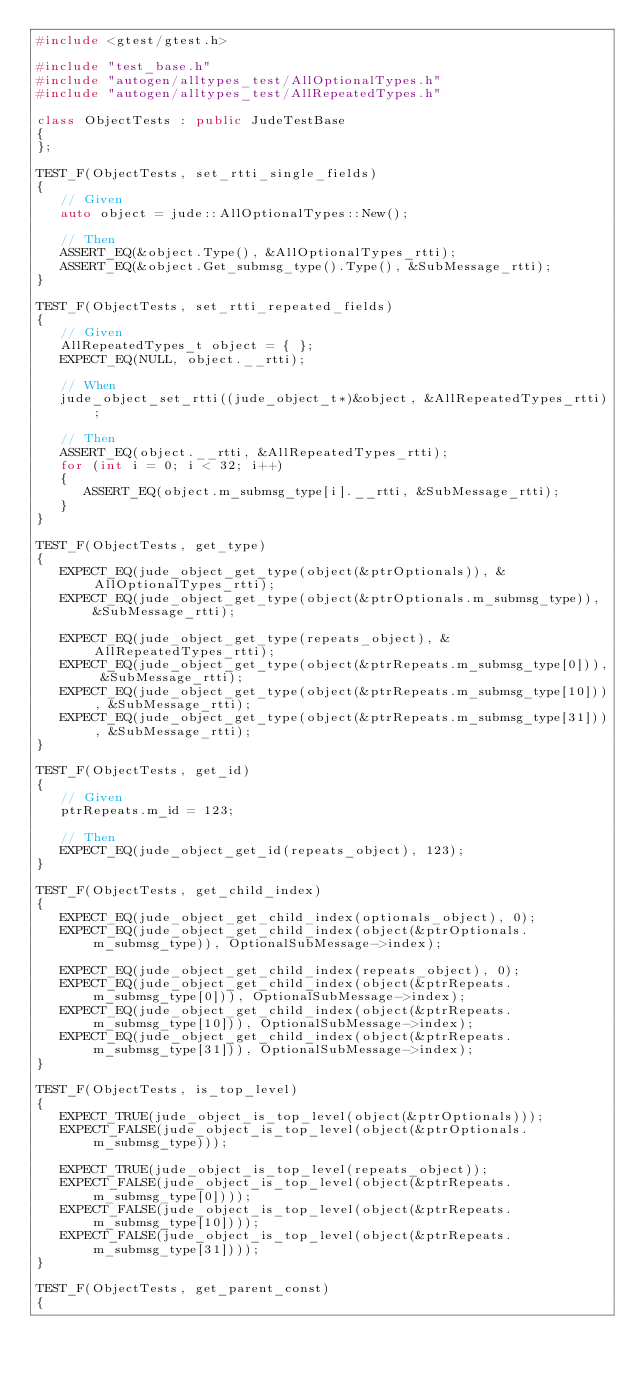Convert code to text. <code><loc_0><loc_0><loc_500><loc_500><_C++_>#include <gtest/gtest.h>

#include "test_base.h"
#include "autogen/alltypes_test/AllOptionalTypes.h"
#include "autogen/alltypes_test/AllRepeatedTypes.h"

class ObjectTests : public JudeTestBase
{
};

TEST_F(ObjectTests, set_rtti_single_fields)
{
   // Given
   auto object = jude::AllOptionalTypes::New();

   // Then
   ASSERT_EQ(&object.Type(), &AllOptionalTypes_rtti);
   ASSERT_EQ(&object.Get_submsg_type().Type(), &SubMessage_rtti);
}

TEST_F(ObjectTests, set_rtti_repeated_fields)
{
   // Given
   AllRepeatedTypes_t object = { };
   EXPECT_EQ(NULL, object.__rtti);

   // When
   jude_object_set_rtti((jude_object_t*)&object, &AllRepeatedTypes_rtti);

   // Then
   ASSERT_EQ(object.__rtti, &AllRepeatedTypes_rtti);
   for (int i = 0; i < 32; i++)
   {
      ASSERT_EQ(object.m_submsg_type[i].__rtti, &SubMessage_rtti);
   }
}

TEST_F(ObjectTests, get_type)
{
   EXPECT_EQ(jude_object_get_type(object(&ptrOptionals)), &AllOptionalTypes_rtti);
   EXPECT_EQ(jude_object_get_type(object(&ptrOptionals.m_submsg_type)), &SubMessage_rtti);

   EXPECT_EQ(jude_object_get_type(repeats_object), &AllRepeatedTypes_rtti);
   EXPECT_EQ(jude_object_get_type(object(&ptrRepeats.m_submsg_type[0])), &SubMessage_rtti);
   EXPECT_EQ(jude_object_get_type(object(&ptrRepeats.m_submsg_type[10])), &SubMessage_rtti);
   EXPECT_EQ(jude_object_get_type(object(&ptrRepeats.m_submsg_type[31])), &SubMessage_rtti);
}

TEST_F(ObjectTests, get_id)
{
   // Given
   ptrRepeats.m_id = 123;

   // Then
   EXPECT_EQ(jude_object_get_id(repeats_object), 123);
}

TEST_F(ObjectTests, get_child_index)
{
   EXPECT_EQ(jude_object_get_child_index(optionals_object), 0);
   EXPECT_EQ(jude_object_get_child_index(object(&ptrOptionals.m_submsg_type)), OptionalSubMessage->index);

   EXPECT_EQ(jude_object_get_child_index(repeats_object), 0);
   EXPECT_EQ(jude_object_get_child_index(object(&ptrRepeats.m_submsg_type[0])), OptionalSubMessage->index);
   EXPECT_EQ(jude_object_get_child_index(object(&ptrRepeats.m_submsg_type[10])), OptionalSubMessage->index);
   EXPECT_EQ(jude_object_get_child_index(object(&ptrRepeats.m_submsg_type[31])), OptionalSubMessage->index);
}

TEST_F(ObjectTests, is_top_level)
{
   EXPECT_TRUE(jude_object_is_top_level(object(&ptrOptionals)));
   EXPECT_FALSE(jude_object_is_top_level(object(&ptrOptionals.m_submsg_type)));

   EXPECT_TRUE(jude_object_is_top_level(repeats_object));
   EXPECT_FALSE(jude_object_is_top_level(object(&ptrRepeats.m_submsg_type[0])));
   EXPECT_FALSE(jude_object_is_top_level(object(&ptrRepeats.m_submsg_type[10])));
   EXPECT_FALSE(jude_object_is_top_level(object(&ptrRepeats.m_submsg_type[31])));
}

TEST_F(ObjectTests, get_parent_const)
{</code> 